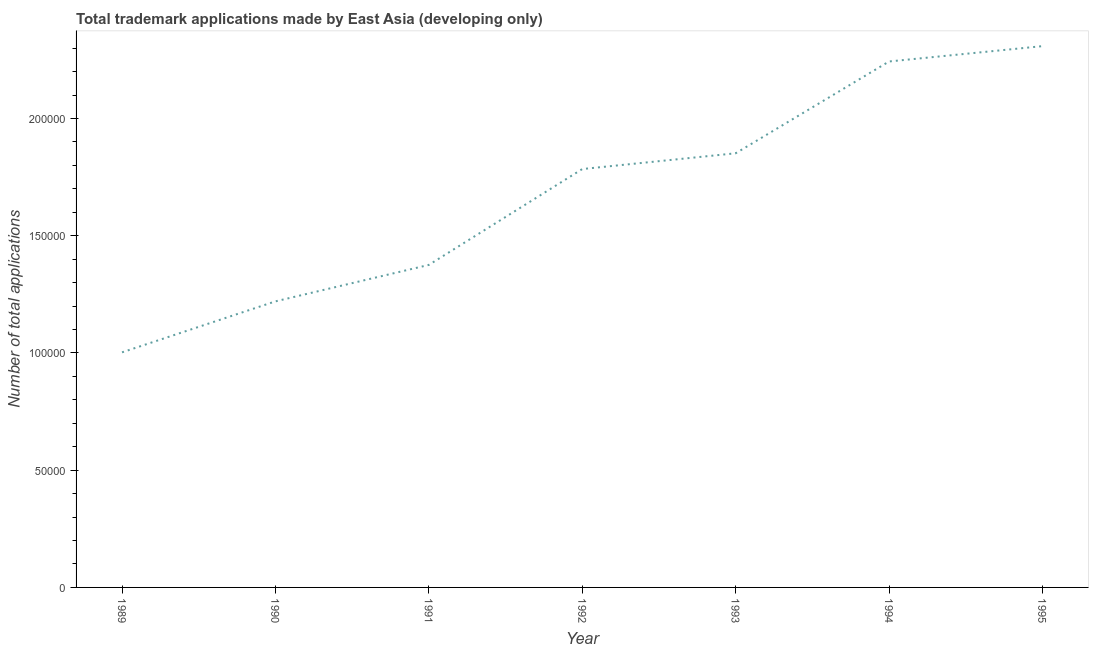What is the number of trademark applications in 1992?
Give a very brief answer. 1.78e+05. Across all years, what is the maximum number of trademark applications?
Provide a succinct answer. 2.31e+05. Across all years, what is the minimum number of trademark applications?
Give a very brief answer. 1.00e+05. What is the sum of the number of trademark applications?
Your answer should be very brief. 1.18e+06. What is the difference between the number of trademark applications in 1991 and 1992?
Provide a short and direct response. -4.09e+04. What is the average number of trademark applications per year?
Provide a succinct answer. 1.68e+05. What is the median number of trademark applications?
Make the answer very short. 1.78e+05. In how many years, is the number of trademark applications greater than 120000 ?
Ensure brevity in your answer.  6. Do a majority of the years between 1994 and 1992 (inclusive) have number of trademark applications greater than 180000 ?
Your response must be concise. No. What is the ratio of the number of trademark applications in 1989 to that in 1990?
Make the answer very short. 0.82. What is the difference between the highest and the second highest number of trademark applications?
Give a very brief answer. 6543. Is the sum of the number of trademark applications in 1989 and 1993 greater than the maximum number of trademark applications across all years?
Provide a short and direct response. Yes. What is the difference between the highest and the lowest number of trademark applications?
Keep it short and to the point. 1.31e+05. In how many years, is the number of trademark applications greater than the average number of trademark applications taken over all years?
Your answer should be compact. 4. Does the number of trademark applications monotonically increase over the years?
Provide a short and direct response. Yes. How many lines are there?
Provide a short and direct response. 1. What is the title of the graph?
Give a very brief answer. Total trademark applications made by East Asia (developing only). What is the label or title of the Y-axis?
Your response must be concise. Number of total applications. What is the Number of total applications in 1989?
Your response must be concise. 1.00e+05. What is the Number of total applications of 1990?
Ensure brevity in your answer.  1.22e+05. What is the Number of total applications of 1991?
Offer a very short reply. 1.38e+05. What is the Number of total applications of 1992?
Your response must be concise. 1.78e+05. What is the Number of total applications of 1993?
Offer a terse response. 1.85e+05. What is the Number of total applications in 1994?
Keep it short and to the point. 2.24e+05. What is the Number of total applications of 1995?
Make the answer very short. 2.31e+05. What is the difference between the Number of total applications in 1989 and 1990?
Provide a succinct answer. -2.17e+04. What is the difference between the Number of total applications in 1989 and 1991?
Provide a short and direct response. -3.73e+04. What is the difference between the Number of total applications in 1989 and 1992?
Provide a succinct answer. -7.82e+04. What is the difference between the Number of total applications in 1989 and 1993?
Offer a very short reply. -8.49e+04. What is the difference between the Number of total applications in 1989 and 1994?
Offer a very short reply. -1.24e+05. What is the difference between the Number of total applications in 1989 and 1995?
Offer a very short reply. -1.31e+05. What is the difference between the Number of total applications in 1990 and 1991?
Keep it short and to the point. -1.56e+04. What is the difference between the Number of total applications in 1990 and 1992?
Your answer should be compact. -5.64e+04. What is the difference between the Number of total applications in 1990 and 1993?
Your response must be concise. -6.32e+04. What is the difference between the Number of total applications in 1990 and 1994?
Provide a succinct answer. -1.02e+05. What is the difference between the Number of total applications in 1990 and 1995?
Ensure brevity in your answer.  -1.09e+05. What is the difference between the Number of total applications in 1991 and 1992?
Give a very brief answer. -4.09e+04. What is the difference between the Number of total applications in 1991 and 1993?
Offer a very short reply. -4.76e+04. What is the difference between the Number of total applications in 1991 and 1994?
Keep it short and to the point. -8.68e+04. What is the difference between the Number of total applications in 1991 and 1995?
Offer a terse response. -9.33e+04. What is the difference between the Number of total applications in 1992 and 1993?
Offer a very short reply. -6730. What is the difference between the Number of total applications in 1992 and 1994?
Keep it short and to the point. -4.59e+04. What is the difference between the Number of total applications in 1992 and 1995?
Make the answer very short. -5.24e+04. What is the difference between the Number of total applications in 1993 and 1994?
Your response must be concise. -3.92e+04. What is the difference between the Number of total applications in 1993 and 1995?
Your response must be concise. -4.57e+04. What is the difference between the Number of total applications in 1994 and 1995?
Provide a succinct answer. -6543. What is the ratio of the Number of total applications in 1989 to that in 1990?
Ensure brevity in your answer.  0.82. What is the ratio of the Number of total applications in 1989 to that in 1991?
Provide a short and direct response. 0.73. What is the ratio of the Number of total applications in 1989 to that in 1992?
Your answer should be compact. 0.56. What is the ratio of the Number of total applications in 1989 to that in 1993?
Make the answer very short. 0.54. What is the ratio of the Number of total applications in 1989 to that in 1994?
Ensure brevity in your answer.  0.45. What is the ratio of the Number of total applications in 1989 to that in 1995?
Provide a short and direct response. 0.43. What is the ratio of the Number of total applications in 1990 to that in 1991?
Your answer should be very brief. 0.89. What is the ratio of the Number of total applications in 1990 to that in 1992?
Your answer should be very brief. 0.68. What is the ratio of the Number of total applications in 1990 to that in 1993?
Offer a terse response. 0.66. What is the ratio of the Number of total applications in 1990 to that in 1994?
Your response must be concise. 0.54. What is the ratio of the Number of total applications in 1990 to that in 1995?
Offer a terse response. 0.53. What is the ratio of the Number of total applications in 1991 to that in 1992?
Give a very brief answer. 0.77. What is the ratio of the Number of total applications in 1991 to that in 1993?
Give a very brief answer. 0.74. What is the ratio of the Number of total applications in 1991 to that in 1994?
Give a very brief answer. 0.61. What is the ratio of the Number of total applications in 1991 to that in 1995?
Your answer should be very brief. 0.6. What is the ratio of the Number of total applications in 1992 to that in 1993?
Ensure brevity in your answer.  0.96. What is the ratio of the Number of total applications in 1992 to that in 1994?
Provide a succinct answer. 0.8. What is the ratio of the Number of total applications in 1992 to that in 1995?
Provide a short and direct response. 0.77. What is the ratio of the Number of total applications in 1993 to that in 1994?
Provide a short and direct response. 0.82. What is the ratio of the Number of total applications in 1993 to that in 1995?
Ensure brevity in your answer.  0.8. 